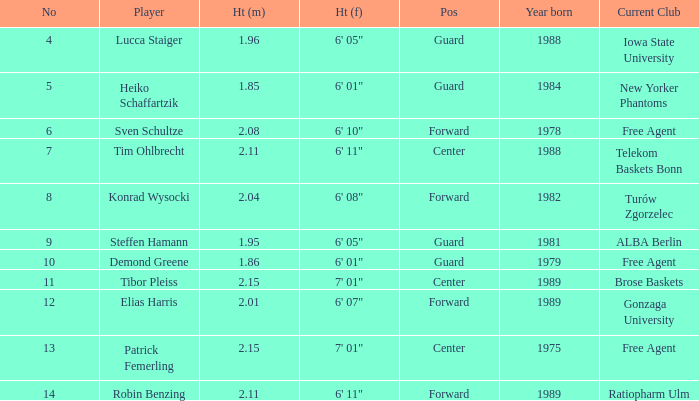Name the height for the player born in 1981 1.95. 